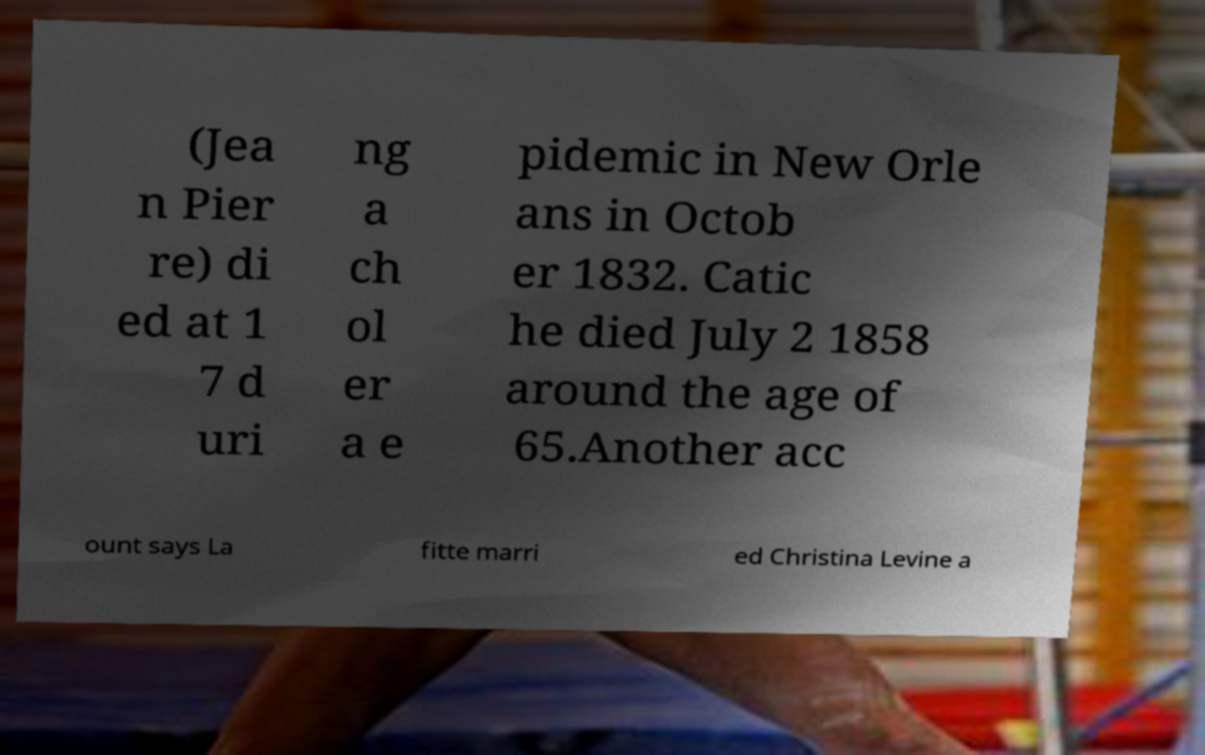Could you extract and type out the text from this image? (Jea n Pier re) di ed at 1 7 d uri ng a ch ol er a e pidemic in New Orle ans in Octob er 1832. Catic he died July 2 1858 around the age of 65.Another acc ount says La fitte marri ed Christina Levine a 